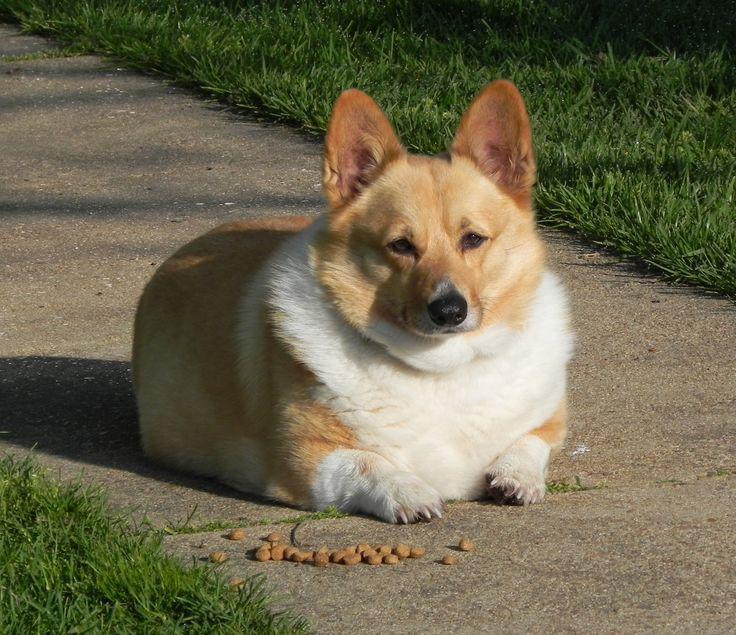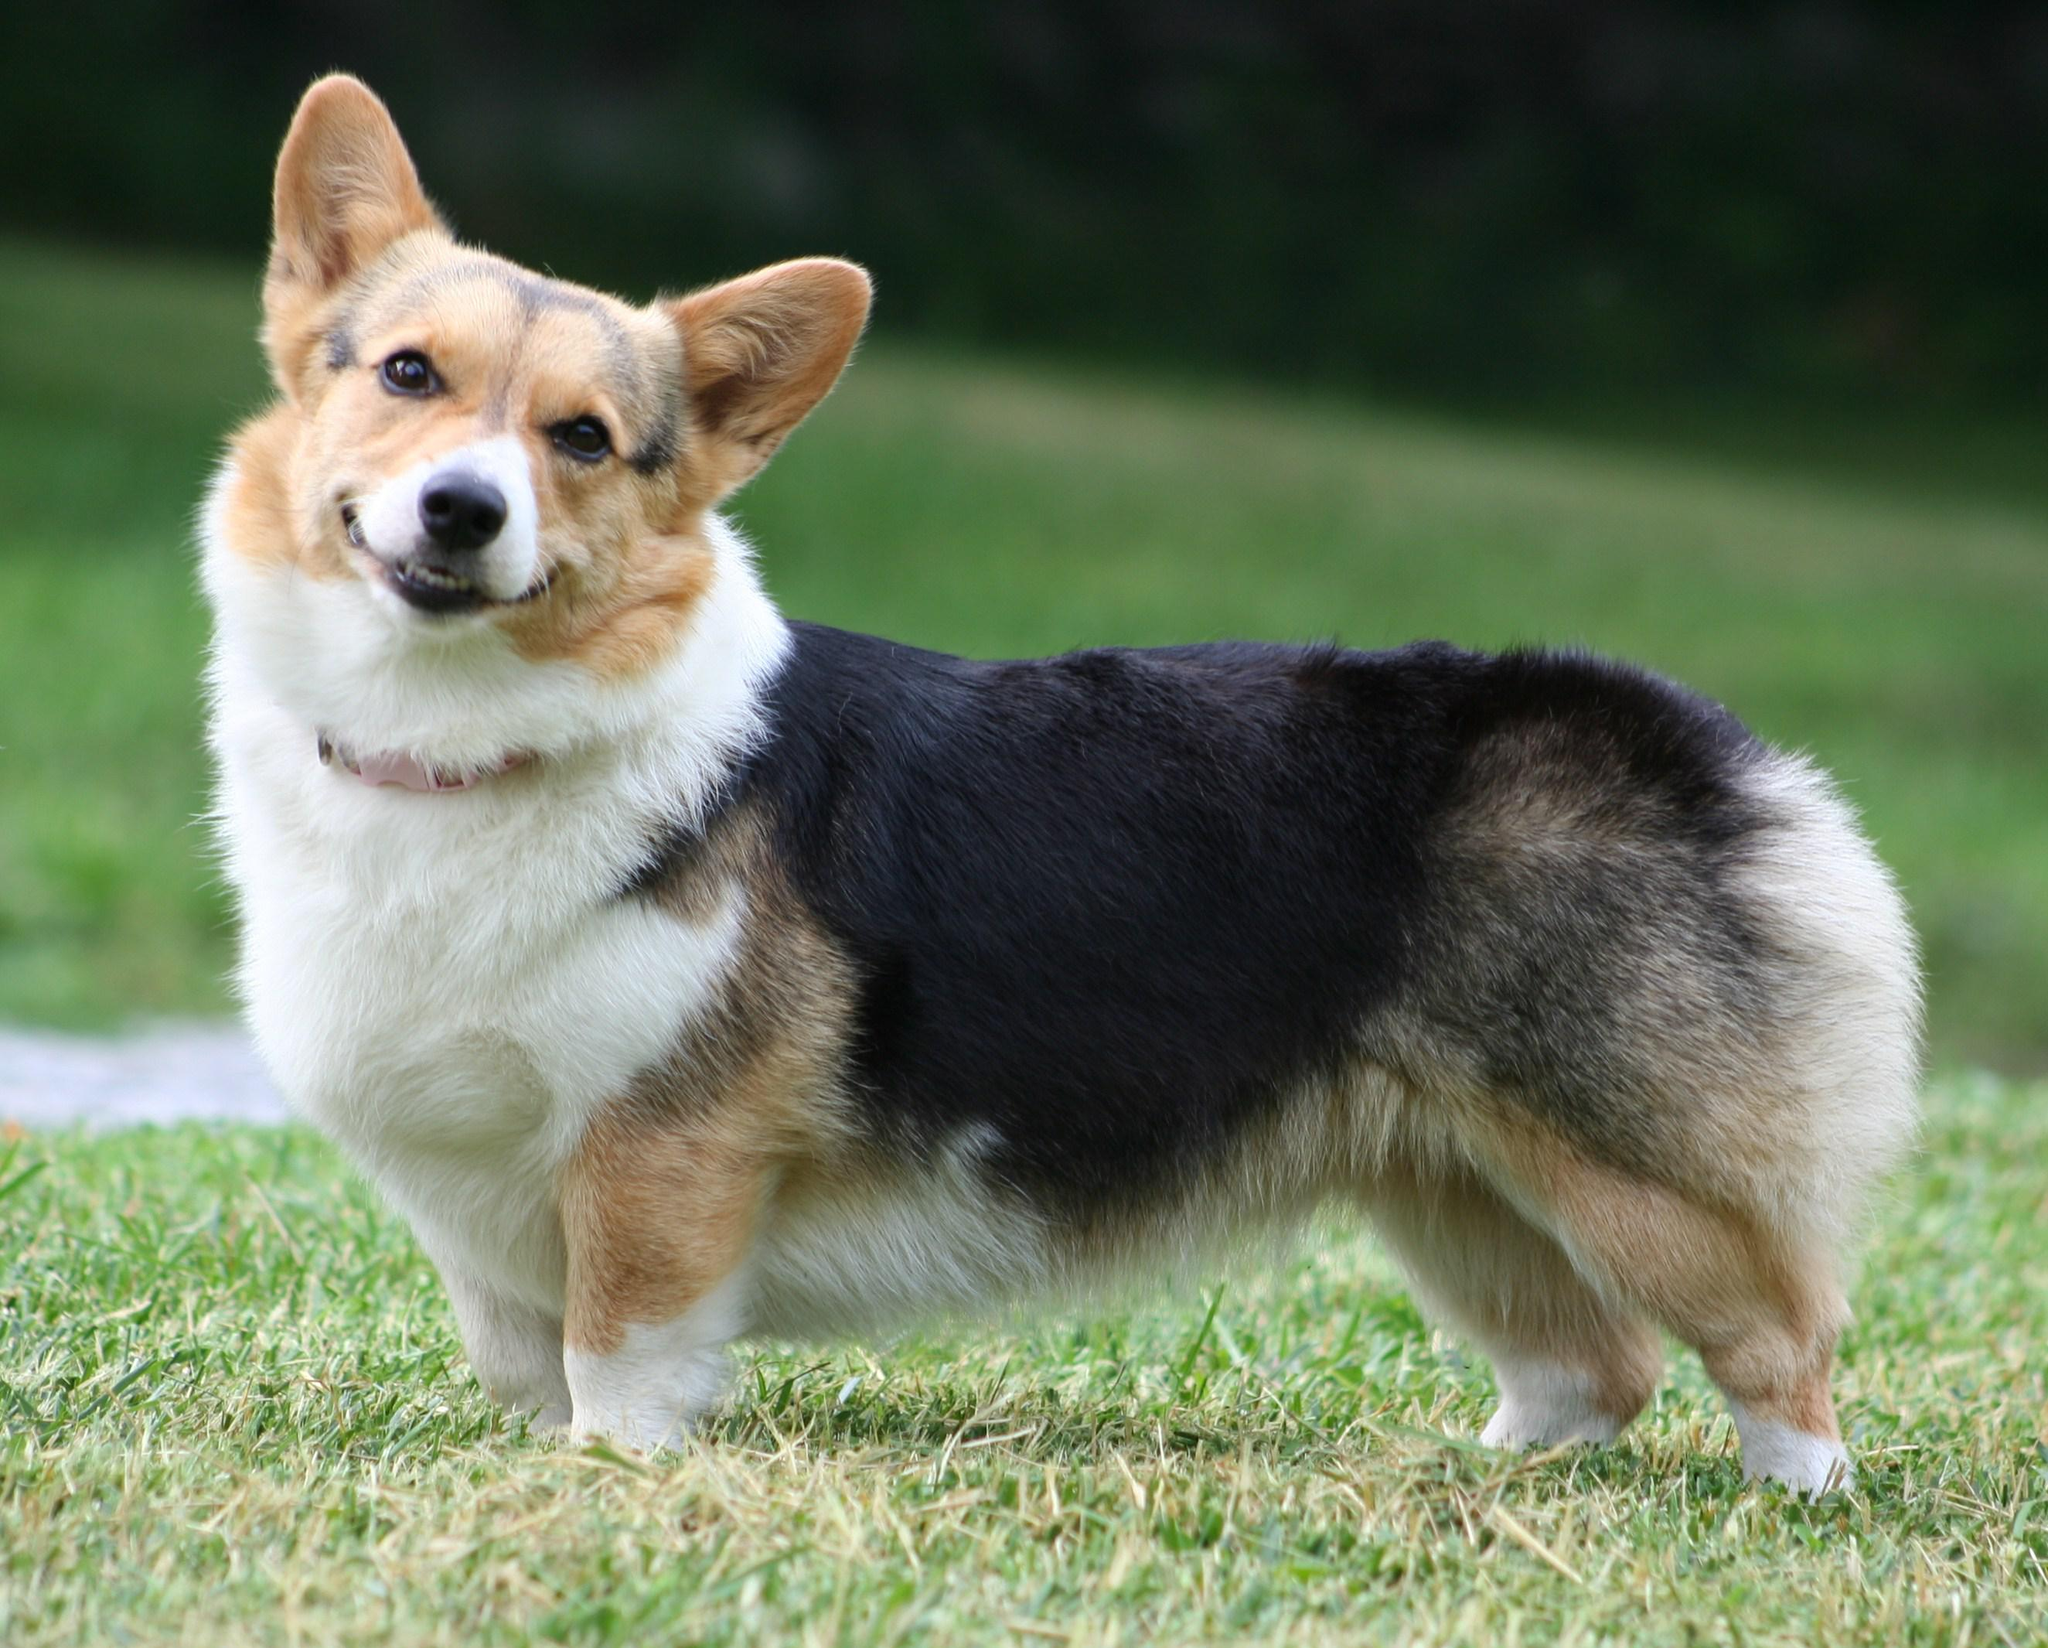The first image is the image on the left, the second image is the image on the right. Assess this claim about the two images: "All the dogs are facing right in the right image.". Correct or not? Answer yes or no. No. 